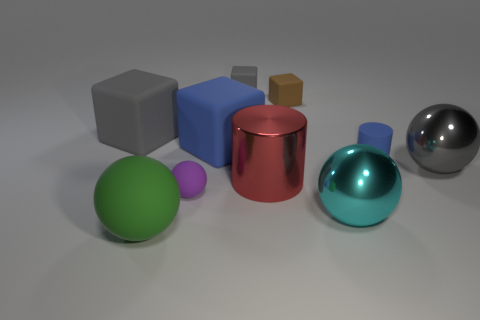Subtract all small spheres. How many spheres are left? 3 Subtract 1 spheres. How many spheres are left? 3 Subtract all cyan balls. How many balls are left? 3 Subtract all spheres. How many objects are left? 6 Subtract all green cylinders. How many gray balls are left? 1 Subtract all tiny gray things. Subtract all big gray metallic cylinders. How many objects are left? 9 Add 5 gray objects. How many gray objects are left? 8 Add 4 cyan metallic things. How many cyan metallic things exist? 5 Subtract 0 yellow balls. How many objects are left? 10 Subtract all gray balls. Subtract all blue cylinders. How many balls are left? 3 